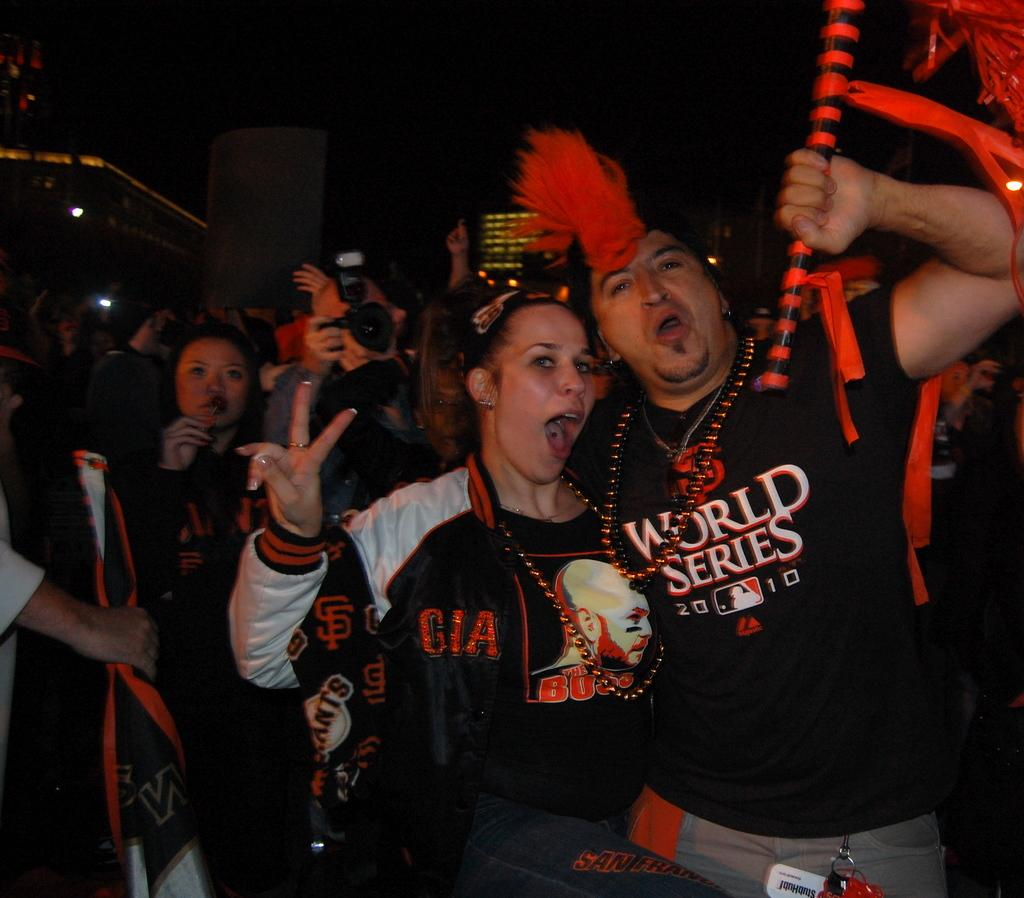What is happening in the image? There are people standing in the image. What are the people holding in their hands? The people are holding objects in their hands. What can be seen in the distance behind the people? There are buildings in the background of the image. What type of meal is being served on the cushion in the image? There is no meal or cushion present in the image. 